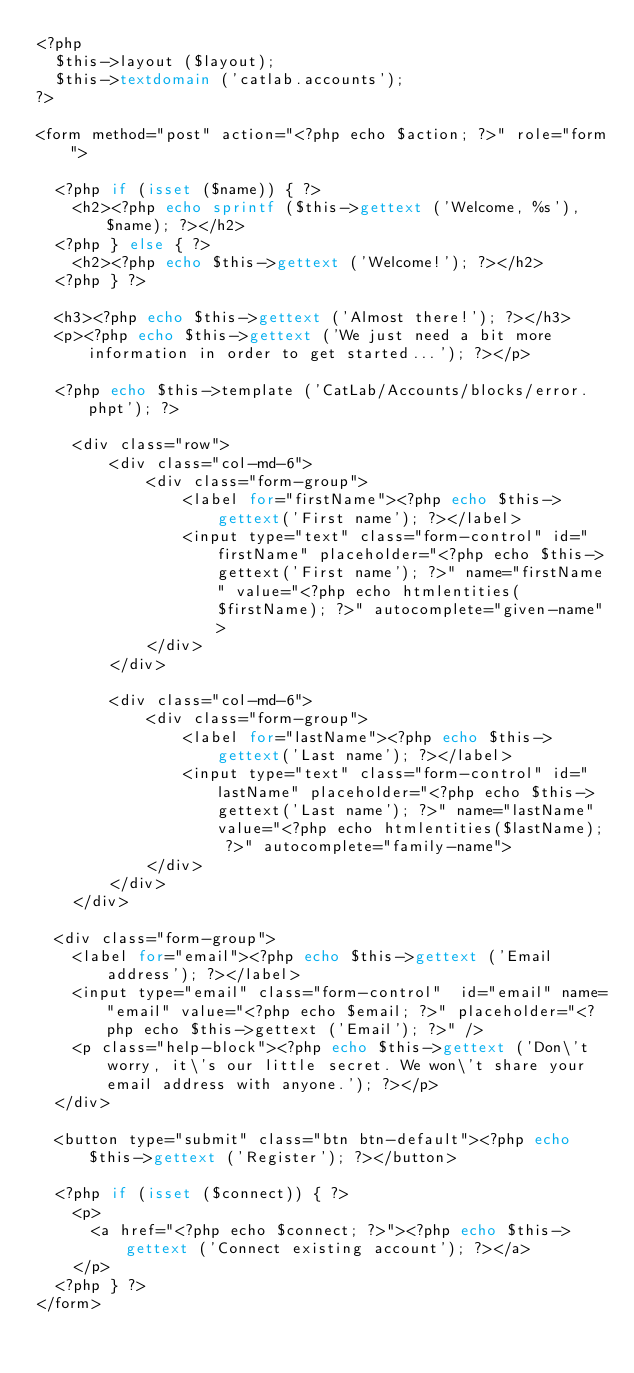Convert code to text. <code><loc_0><loc_0><loc_500><loc_500><_PHP_><?php
	$this->layout ($layout);
	$this->textdomain ('catlab.accounts');
?>

<form method="post" action="<?php echo $action; ?>" role="form">

	<?php if (isset ($name)) { ?>
		<h2><?php echo sprintf ($this->gettext ('Welcome, %s'), $name); ?></h2>
	<?php } else { ?>
		<h2><?php echo $this->gettext ('Welcome!'); ?></h2>
	<?php } ?>

	<h3><?php echo $this->gettext ('Almost there!'); ?></h3>
	<p><?php echo $this->gettext ('We just need a bit more information in order to get started...'); ?></p>

	<?php echo $this->template ('CatLab/Accounts/blocks/error.phpt'); ?>

    <div class="row">
        <div class="col-md-6">
            <div class="form-group">
                <label for="firstName"><?php echo $this->gettext('First name'); ?></label>
                <input type="text" class="form-control" id="firstName" placeholder="<?php echo $this->gettext('First name'); ?>" name="firstName" value="<?php echo htmlentities($firstName); ?>" autocomplete="given-name">
            </div>
        </div>

        <div class="col-md-6">
            <div class="form-group">
                <label for="lastName"><?php echo $this->gettext('Last name'); ?></label>
                <input type="text" class="form-control" id="lastName" placeholder="<?php echo $this->gettext('Last name'); ?>" name="lastName" value="<?php echo htmlentities($lastName); ?>" autocomplete="family-name">
            </div>
        </div>
    </div>

	<div class="form-group">
		<label for="email"><?php echo $this->gettext ('Email address'); ?></label>
		<input type="email" class="form-control"  id="email" name="email" value="<?php echo $email; ?>" placeholder="<?php echo $this->gettext ('Email'); ?>" />
		<p class="help-block"><?php echo $this->gettext ('Don\'t worry, it\'s our little secret. We won\'t share your email address with anyone.'); ?></p>
	</div>

	<button type="submit" class="btn btn-default"><?php echo $this->gettext ('Register'); ?></button>

	<?php if (isset ($connect)) { ?>
		<p>
			<a href="<?php echo $connect; ?>"><?php echo $this->gettext ('Connect existing account'); ?></a>
		</p>
	<?php } ?>
</form>
</code> 